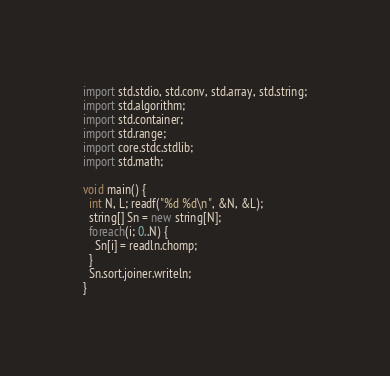<code> <loc_0><loc_0><loc_500><loc_500><_D_>import std.stdio, std.conv, std.array, std.string;
import std.algorithm;
import std.container;
import std.range;
import core.stdc.stdlib;
import std.math;

void main() {
  int N, L; readf("%d %d\n", &N, &L);
  string[] Sn = new string[N];
  foreach(i; 0..N) {
    Sn[i] = readln.chomp;
  }
  Sn.sort.joiner.writeln;
}
</code> 